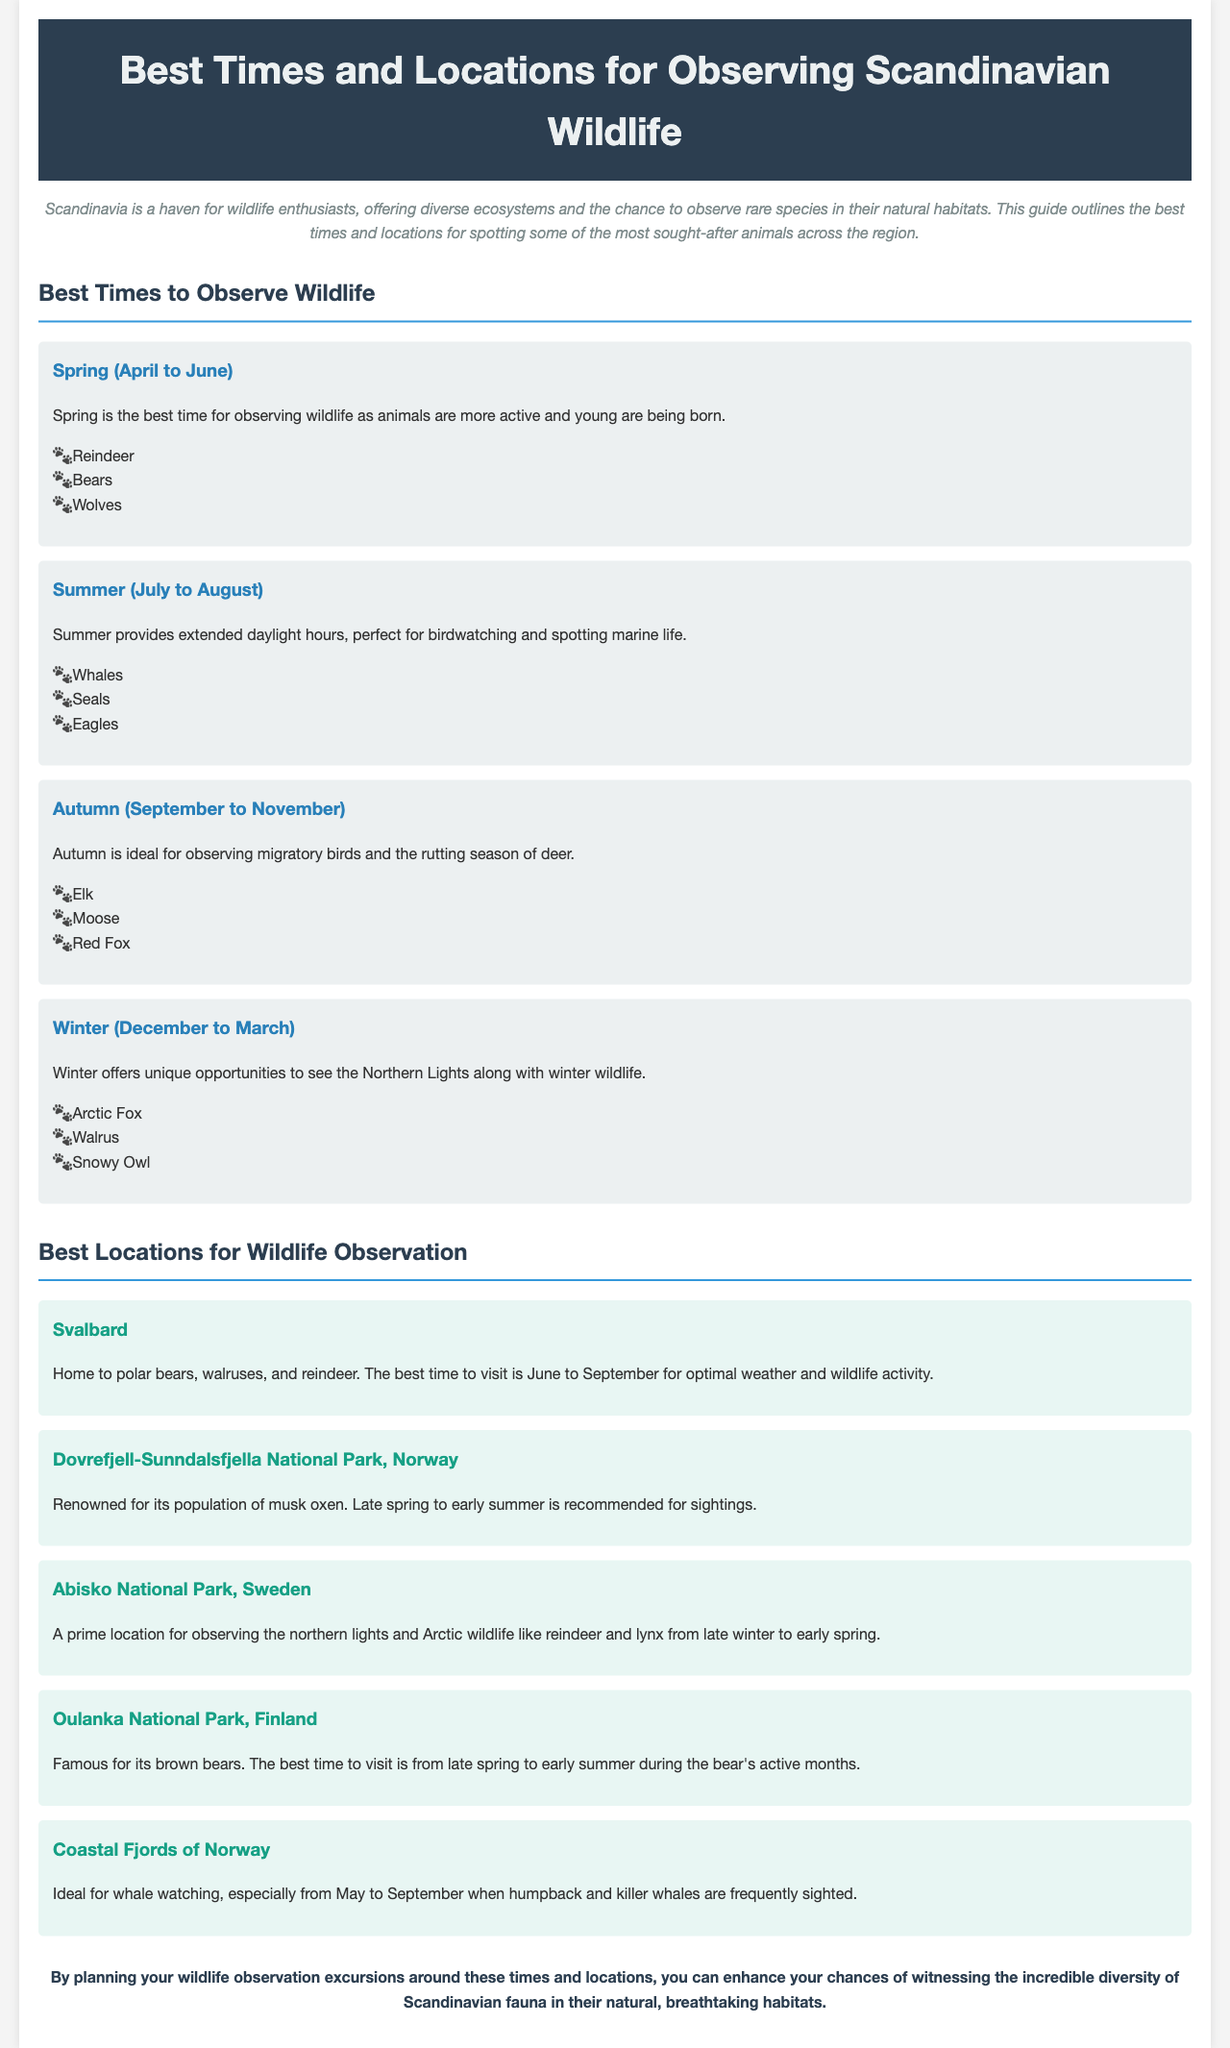what is the best time to observe reindeer? The best time to observe reindeer is in Spring (April to June) when animals are more active and young are being born.
Answer: Spring (April to June) which animal is mentioned as being observed in the autumn? The animals listed for observation in autumn include elk, moose, and red fox.
Answer: Elk what location is famous for its population of musk oxen? The location renowned for its population of musk oxen is Dovrefjell-Sunndalsfjella National Park, Norway.
Answer: Dovrefjell-Sunndalsfjella National Park, Norway during which months is whale watching ideal in the Coastal Fjords of Norway? The ideal months for whale watching in the Coastal Fjords of Norway are from May to September.
Answer: May to September which animal can be observed in Abisko National Park? The animals that can be observed in Abisko National Park include reindeer and lynx.
Answer: Reindeer and lynx what unique opportunity does winter provide for wildlife observation? Winter offers unique opportunities to see the Northern Lights along with winter wildlife.
Answer: Northern Lights which animal is specifically mentioned for Oulanka National Park? The animal specifically mentioned for Oulanka National Park is brown bears.
Answer: Brown bears what does the conclusion suggest to enhance wildlife observation chances? The conclusion suggests planning wildlife observation excursions around the best times and locations listed in the guide.
Answer: Planning excursions around the best times and locations 